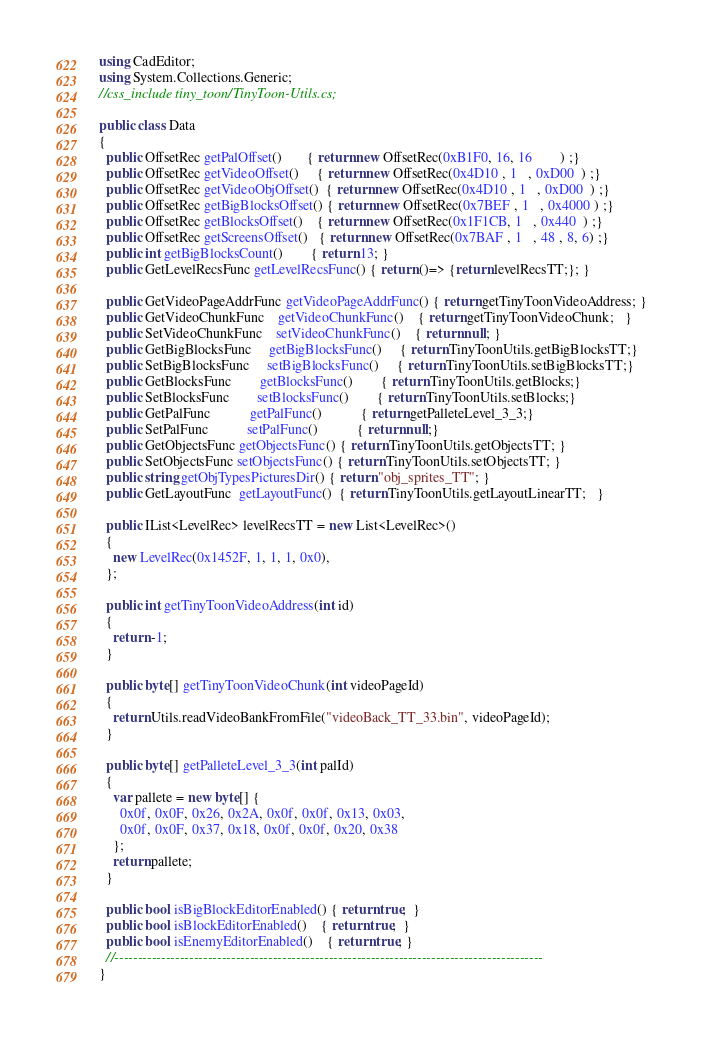<code> <loc_0><loc_0><loc_500><loc_500><_C#_>using CadEditor;
using System.Collections.Generic;
//css_include tiny_toon/TinyToon-Utils.cs;

public class Data
{ 
  public OffsetRec getPalOffset()       { return new OffsetRec(0xB1F0, 16, 16        ) ;}
  public OffsetRec getVideoOffset()     { return new OffsetRec(0x4D10 , 1   , 0xD00  ) ;}
  public OffsetRec getVideoObjOffset()  { return new OffsetRec(0x4D10 , 1   , 0xD00  ) ;}
  public OffsetRec getBigBlocksOffset() { return new OffsetRec(0x7BEF , 1   , 0x4000 ) ;}
  public OffsetRec getBlocksOffset()    { return new OffsetRec(0x1F1CB, 1   , 0x440  ) ;}
  public OffsetRec getScreensOffset()   { return new OffsetRec(0x7BAF , 1   , 48 , 8, 6) ;}
  public int getBigBlocksCount()        { return 13; }
  public GetLevelRecsFunc getLevelRecsFunc() { return ()=> {return levelRecsTT;}; }
  
  public GetVideoPageAddrFunc getVideoPageAddrFunc() { return getTinyToonVideoAddress; }
  public GetVideoChunkFunc    getVideoChunkFunc()    { return getTinyToonVideoChunk;   }
  public SetVideoChunkFunc    setVideoChunkFunc()    { return null; }
  public GetBigBlocksFunc     getBigBlocksFunc()     { return TinyToonUtils.getBigBlocksTT;}
  public SetBigBlocksFunc     setBigBlocksFunc()     { return TinyToonUtils.setBigBlocksTT;}
  public GetBlocksFunc        getBlocksFunc()        { return TinyToonUtils.getBlocks;}
  public SetBlocksFunc        setBlocksFunc()        { return TinyToonUtils.setBlocks;}
  public GetPalFunc           getPalFunc()           { return getPalleteLevel_3_3;}
  public SetPalFunc           setPalFunc()           { return null;}
  public GetObjectsFunc getObjectsFunc() { return TinyToonUtils.getObjectsTT; }
  public SetObjectsFunc setObjectsFunc() { return TinyToonUtils.setObjectsTT; }
  public string getObjTypesPicturesDir() { return "obj_sprites_TT"; }
  public GetLayoutFunc  getLayoutFunc()  { return TinyToonUtils.getLayoutLinearTT;   }
  
  public IList<LevelRec> levelRecsTT = new List<LevelRec>() 
  {
    new LevelRec(0x1452F, 1, 1, 1, 0x0),
  };
  
  public int getTinyToonVideoAddress(int id)
  {
    return -1;
  }
  
  public byte[] getTinyToonVideoChunk(int videoPageId)
  {
    return Utils.readVideoBankFromFile("videoBack_TT_33.bin", videoPageId);
  }
  
  public byte[] getPalleteLevel_3_3(int palId)
  {
    var pallete = new byte[] { 
      0x0f, 0x0F, 0x26, 0x2A, 0x0f, 0x0f, 0x13, 0x03,
      0x0f, 0x0F, 0x37, 0x18, 0x0f, 0x0f, 0x20, 0x38
    }; 
    return pallete;
  }
  
  public bool isBigBlockEditorEnabled() { return true;  }
  public bool isBlockEditorEnabled()    { return true;  }
  public bool isEnemyEditorEnabled()    { return true; }
  //--------------------------------------------------------------------------------------------
}</code> 